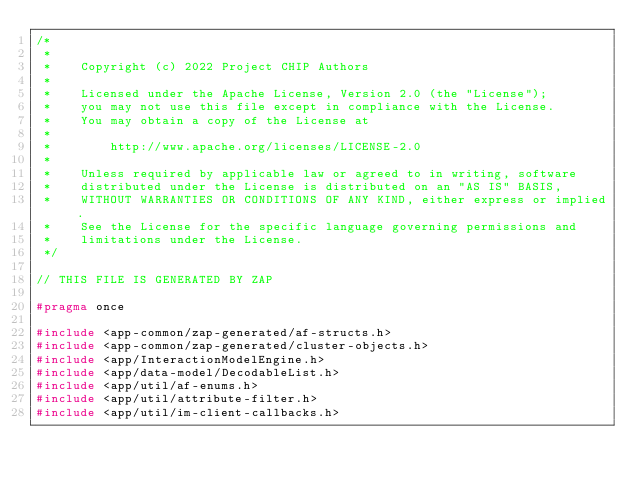Convert code to text. <code><loc_0><loc_0><loc_500><loc_500><_C_>/*
 *
 *    Copyright (c) 2022 Project CHIP Authors
 *
 *    Licensed under the Apache License, Version 2.0 (the "License");
 *    you may not use this file except in compliance with the License.
 *    You may obtain a copy of the License at
 *
 *        http://www.apache.org/licenses/LICENSE-2.0
 *
 *    Unless required by applicable law or agreed to in writing, software
 *    distributed under the License is distributed on an "AS IS" BASIS,
 *    WITHOUT WARRANTIES OR CONDITIONS OF ANY KIND, either express or implied.
 *    See the License for the specific language governing permissions and
 *    limitations under the License.
 */

// THIS FILE IS GENERATED BY ZAP

#pragma once

#include <app-common/zap-generated/af-structs.h>
#include <app-common/zap-generated/cluster-objects.h>
#include <app/InteractionModelEngine.h>
#include <app/data-model/DecodableList.h>
#include <app/util/af-enums.h>
#include <app/util/attribute-filter.h>
#include <app/util/im-client-callbacks.h></code> 